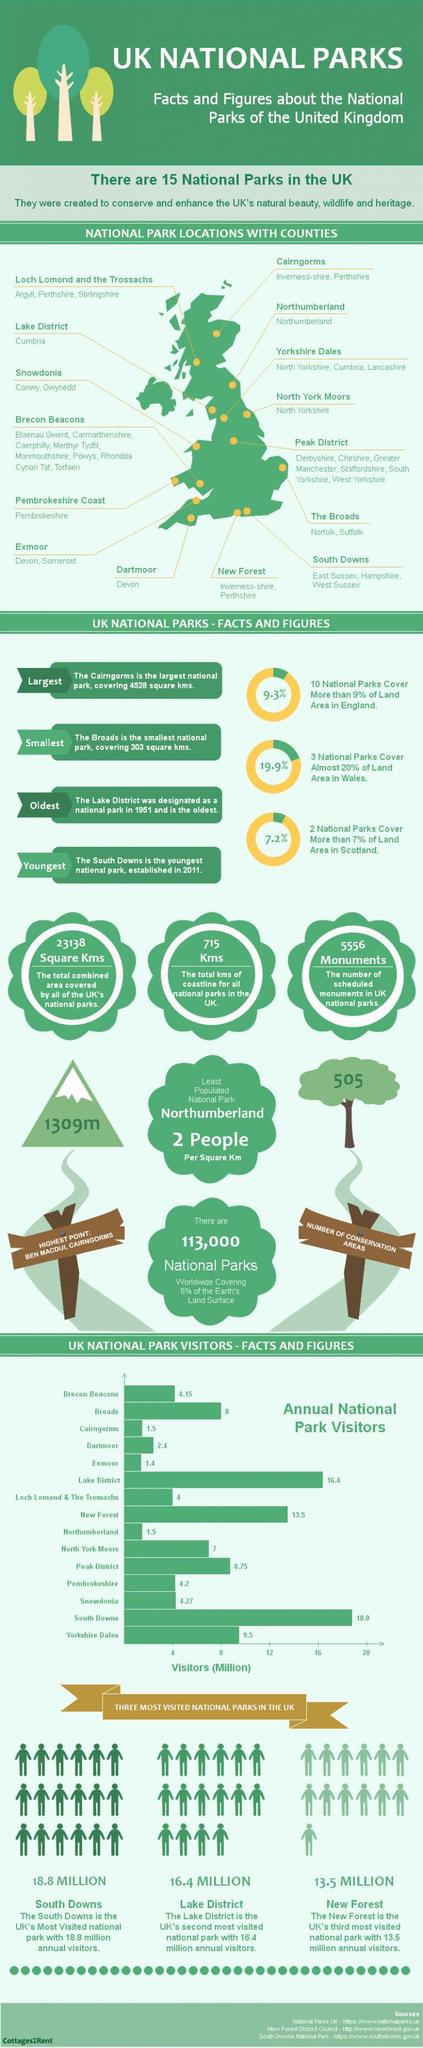How many people visited (in millions) the North York Moors National Park?
Answer the question with a short phrase. 7 What is the total kms of coastline for all national parks in the UK? 715 What is the total combined area (in square kms) covered by all of the UK's national parks? 23138 What is the number of scheduled monuments in UK national parks? 5556 Monuments How many people visited (in millions) the Northumberland National Park? 1.5 